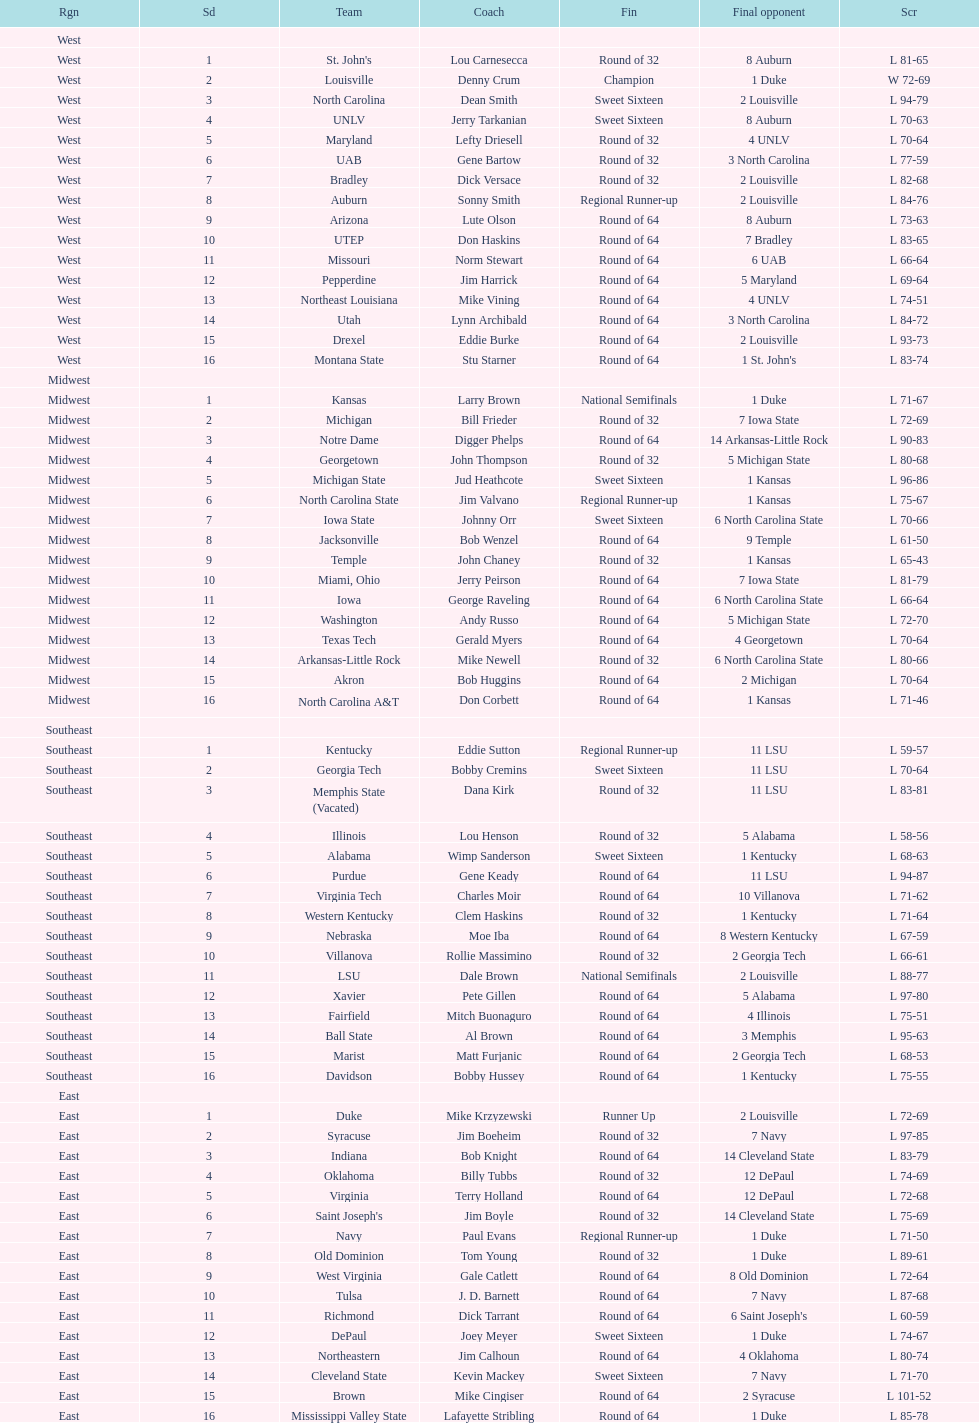How many 1 seeds are there? 4. 